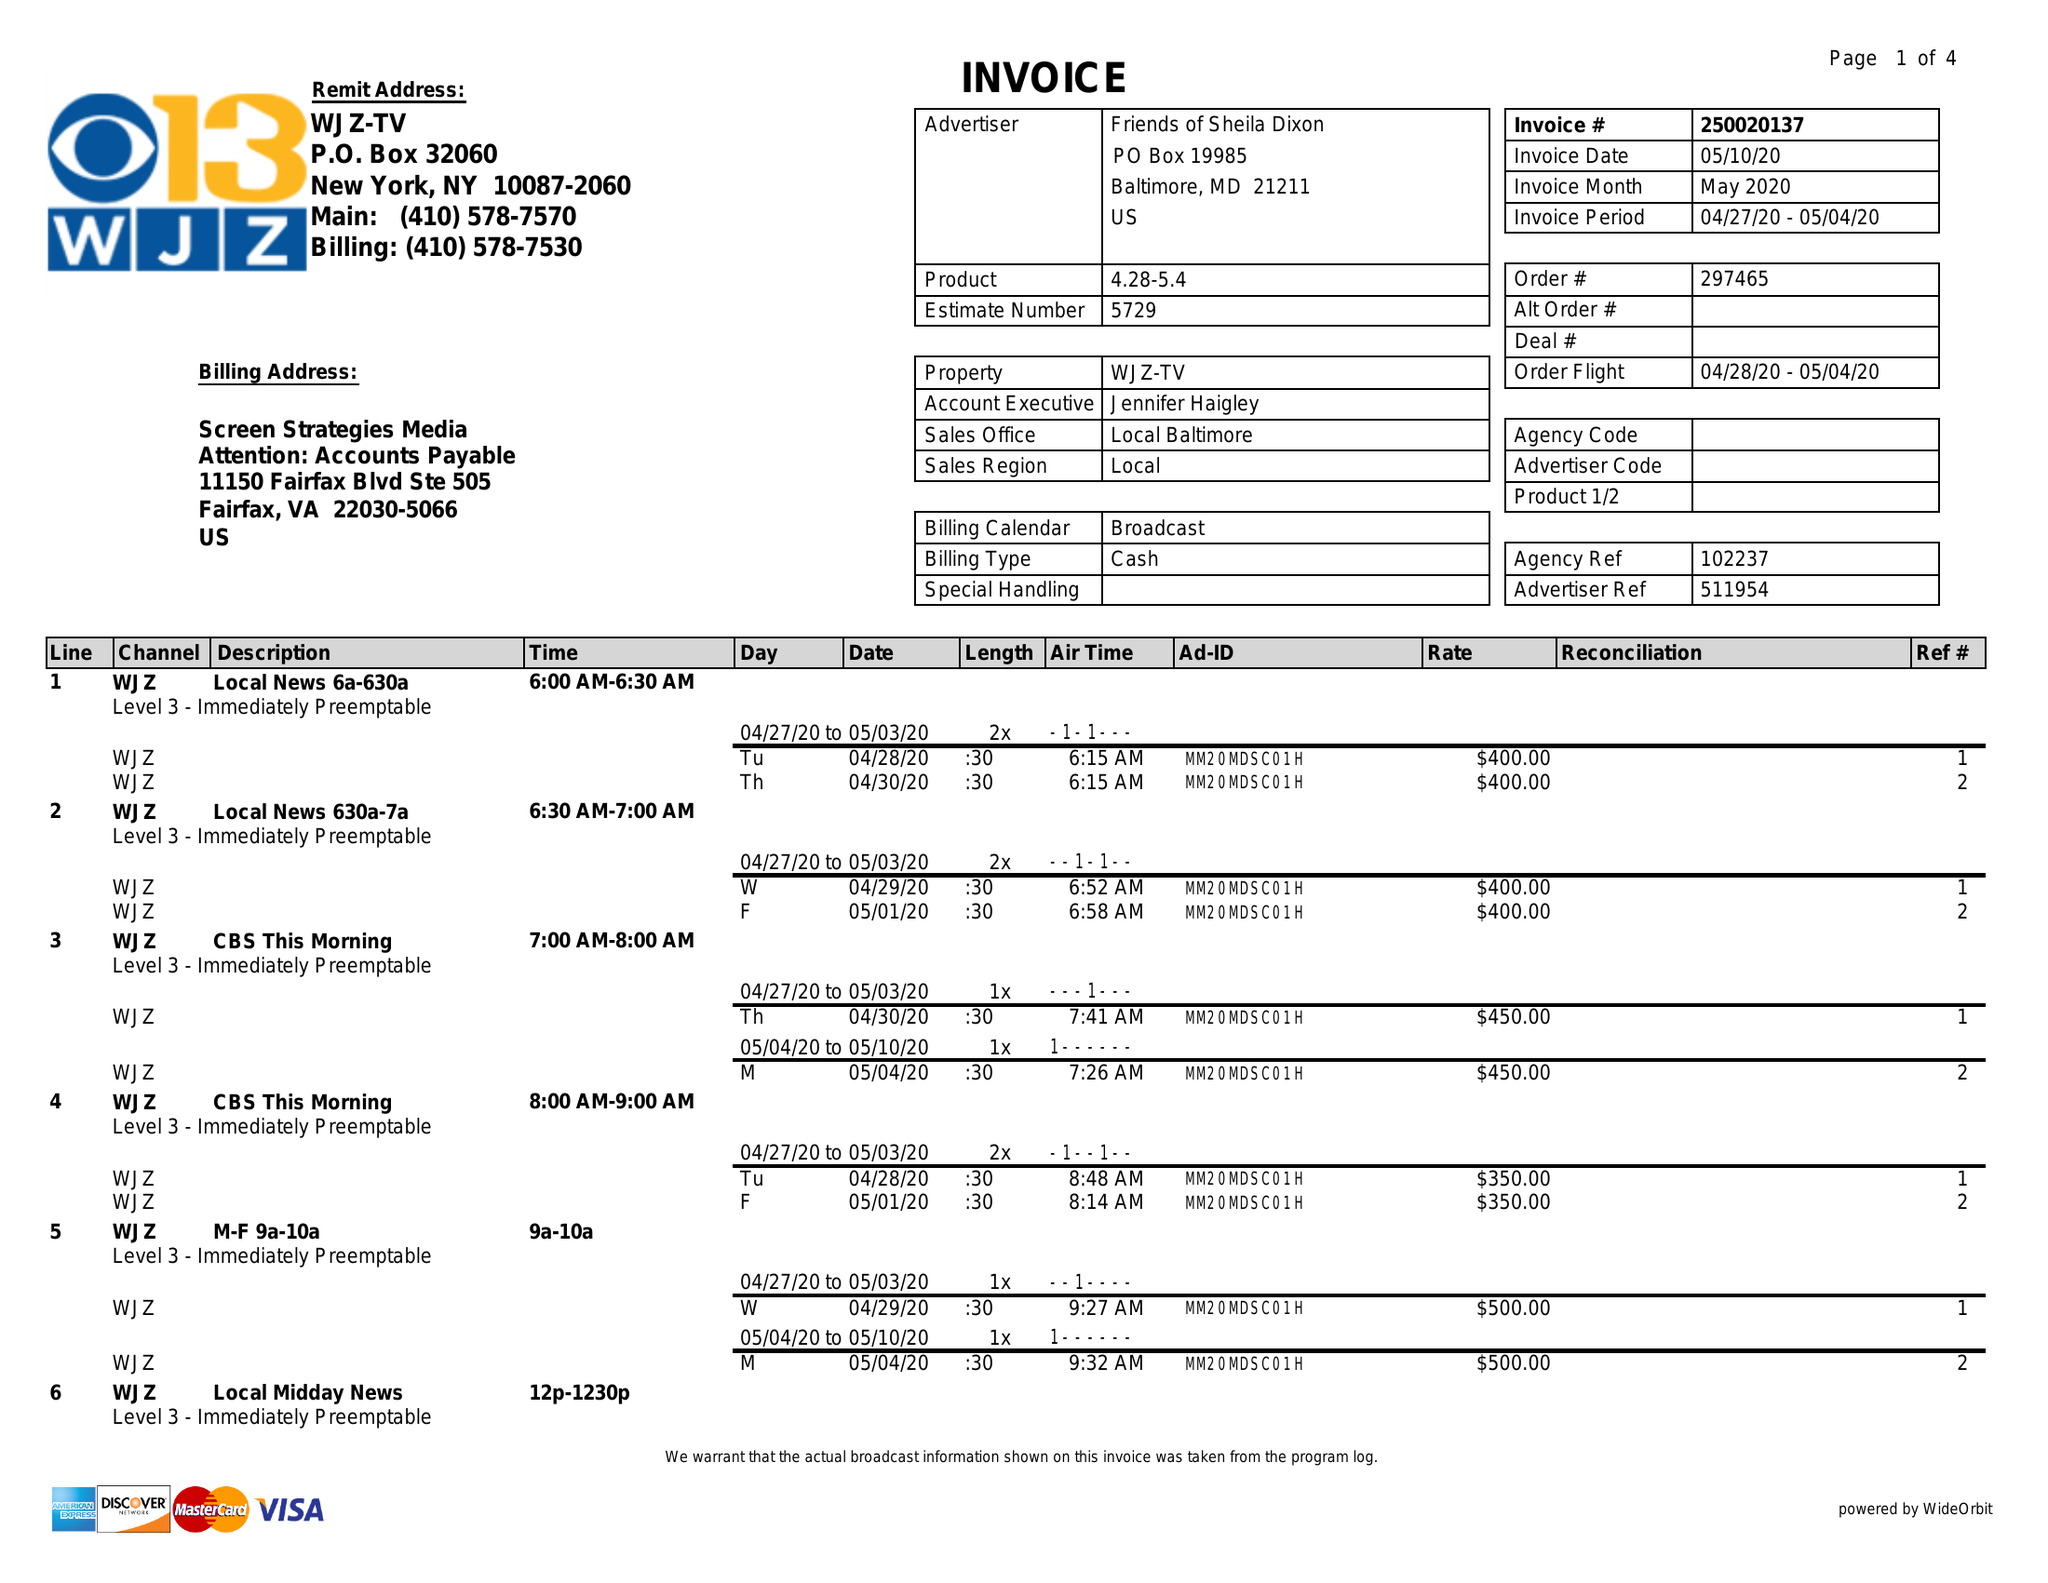What is the value for the contract_num?
Answer the question using a single word or phrase. 250020137 